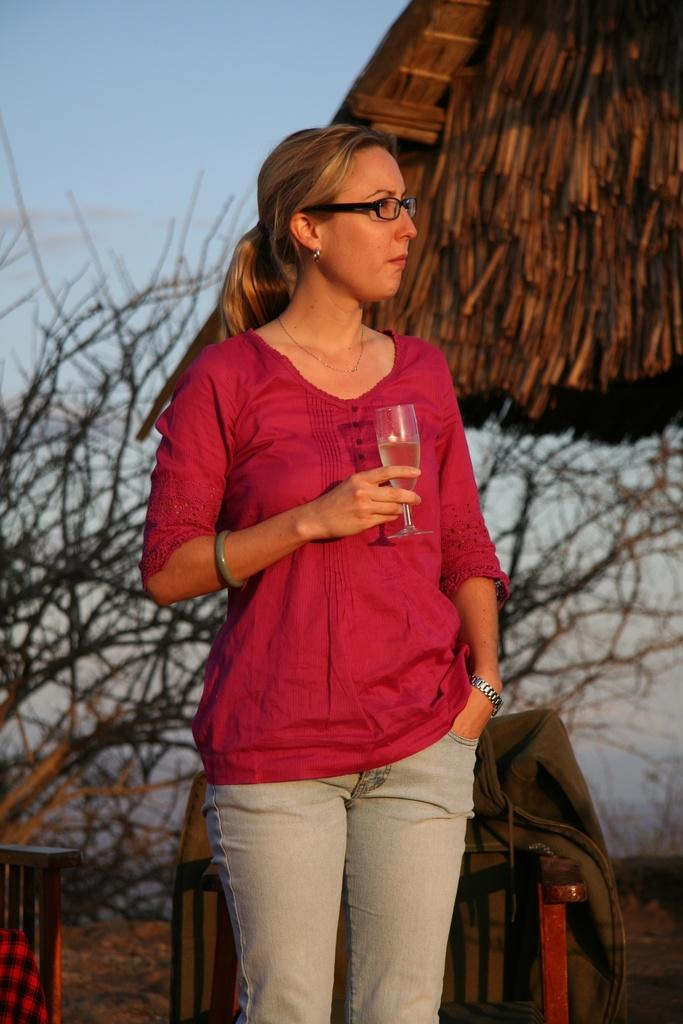Who is the main subject in the image? There is a girl in the image. What is the girl wearing? The girl is wearing a bangle, a watch, and specs. She is also wearing a red dress. What is the girl holding in the image? The girl is holding a glass. What type of furniture can be seen in the image? There are chairs in the image. What is placed on the chairs? There is a jacket on the chairs. What can be seen in the background of the image? There is a tree and the sky visible in the background of the image. Is the girl wearing a mask and standing on the seashore in the image? No, the girl is not wearing a mask, and there is no seashore present in the image. 